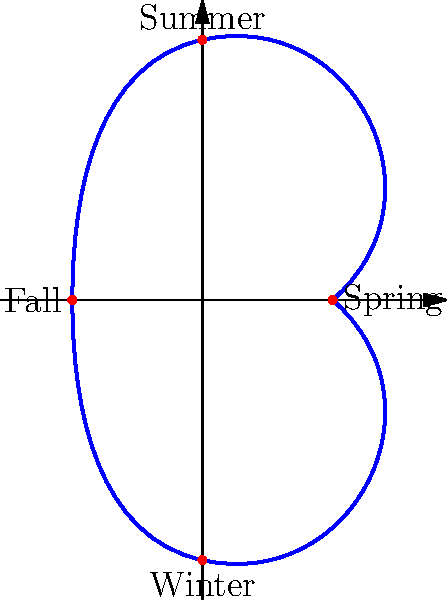The seasonal growth pattern of a medicinal herb follows a cyclic group structure, as shown in the polar graph. If the order of this cyclic group is 4, corresponding to the four seasons, what is the generator of this group in terms of the angle of rotation? To determine the generator of this cyclic group, we need to follow these steps:

1. Recognize that the graph represents a full cycle of seasons, which corresponds to a complete rotation of $2\pi$ radians.

2. Observe that the group has order 4, meaning it has 4 elements (Spring, Summer, Fall, Winter).

3. To find the generator, we need to determine the smallest rotation that, when repeated, generates all elements of the group.

4. Since there are 4 elements and a full rotation is $2\pi$, the smallest rotation that generates the group is:

   $$\frac{2\pi}{4} = \frac{\pi}{2}$$ radians

5. This $\frac{\pi}{2}$ rotation corresponds to moving from one season to the next in the cyclic pattern.

6. Applying this rotation four times brings us back to the starting point, generating all elements of the group.

Therefore, the generator of this cyclic group is a rotation by $\frac{\pi}{2}$ radians.
Answer: $\frac{\pi}{2}$ radians 